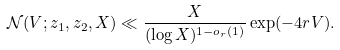Convert formula to latex. <formula><loc_0><loc_0><loc_500><loc_500>\mathcal { N } ( V ; z _ { 1 } , z _ { 2 } , X ) \ll \frac { X } { ( \log X ) ^ { 1 - o _ { r } ( 1 ) } } \exp ( - 4 r V ) .</formula> 